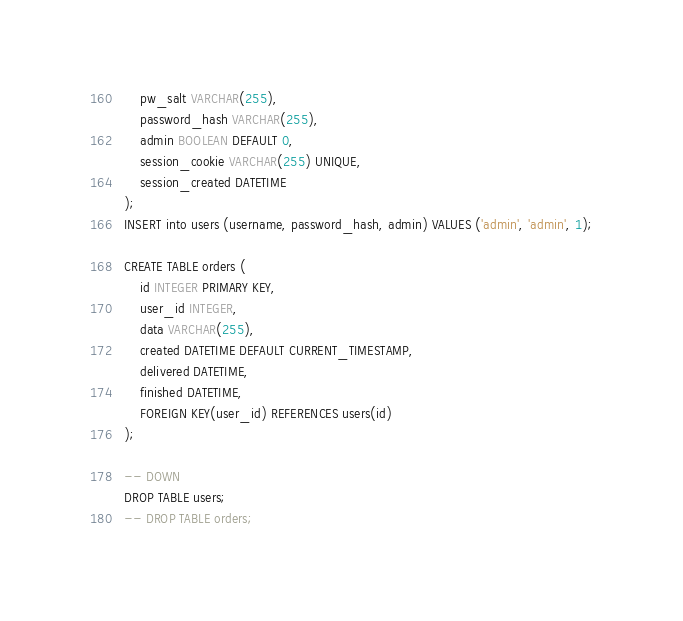<code> <loc_0><loc_0><loc_500><loc_500><_SQL_>    pw_salt VARCHAR(255),
    password_hash VARCHAR(255),
    admin BOOLEAN DEFAULT 0,
    session_cookie VARCHAR(255) UNIQUE,
    session_created DATETIME
);
INSERT into users (username, password_hash, admin) VALUES ('admin', 'admin', 1);

CREATE TABLE orders (
    id INTEGER PRIMARY KEY,
    user_id INTEGER,
    data VARCHAR(255),
    created DATETIME DEFAULT CURRENT_TIMESTAMP,
    delivered DATETIME,
    finished DATETIME,
    FOREIGN KEY(user_id) REFERENCES users(id)
);

-- DOWN
DROP TABLE users;
-- DROP TABLE orders;
</code> 